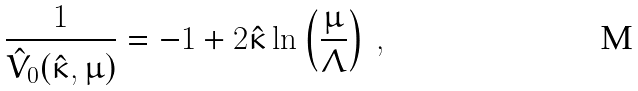Convert formula to latex. <formula><loc_0><loc_0><loc_500><loc_500>\frac { 1 } { \hat { V } _ { 0 } ( \hat { \kappa } , \mu ) } = - 1 + 2 \hat { \kappa } \ln \left ( \frac { \mu } { \Lambda } \right ) \, ,</formula> 